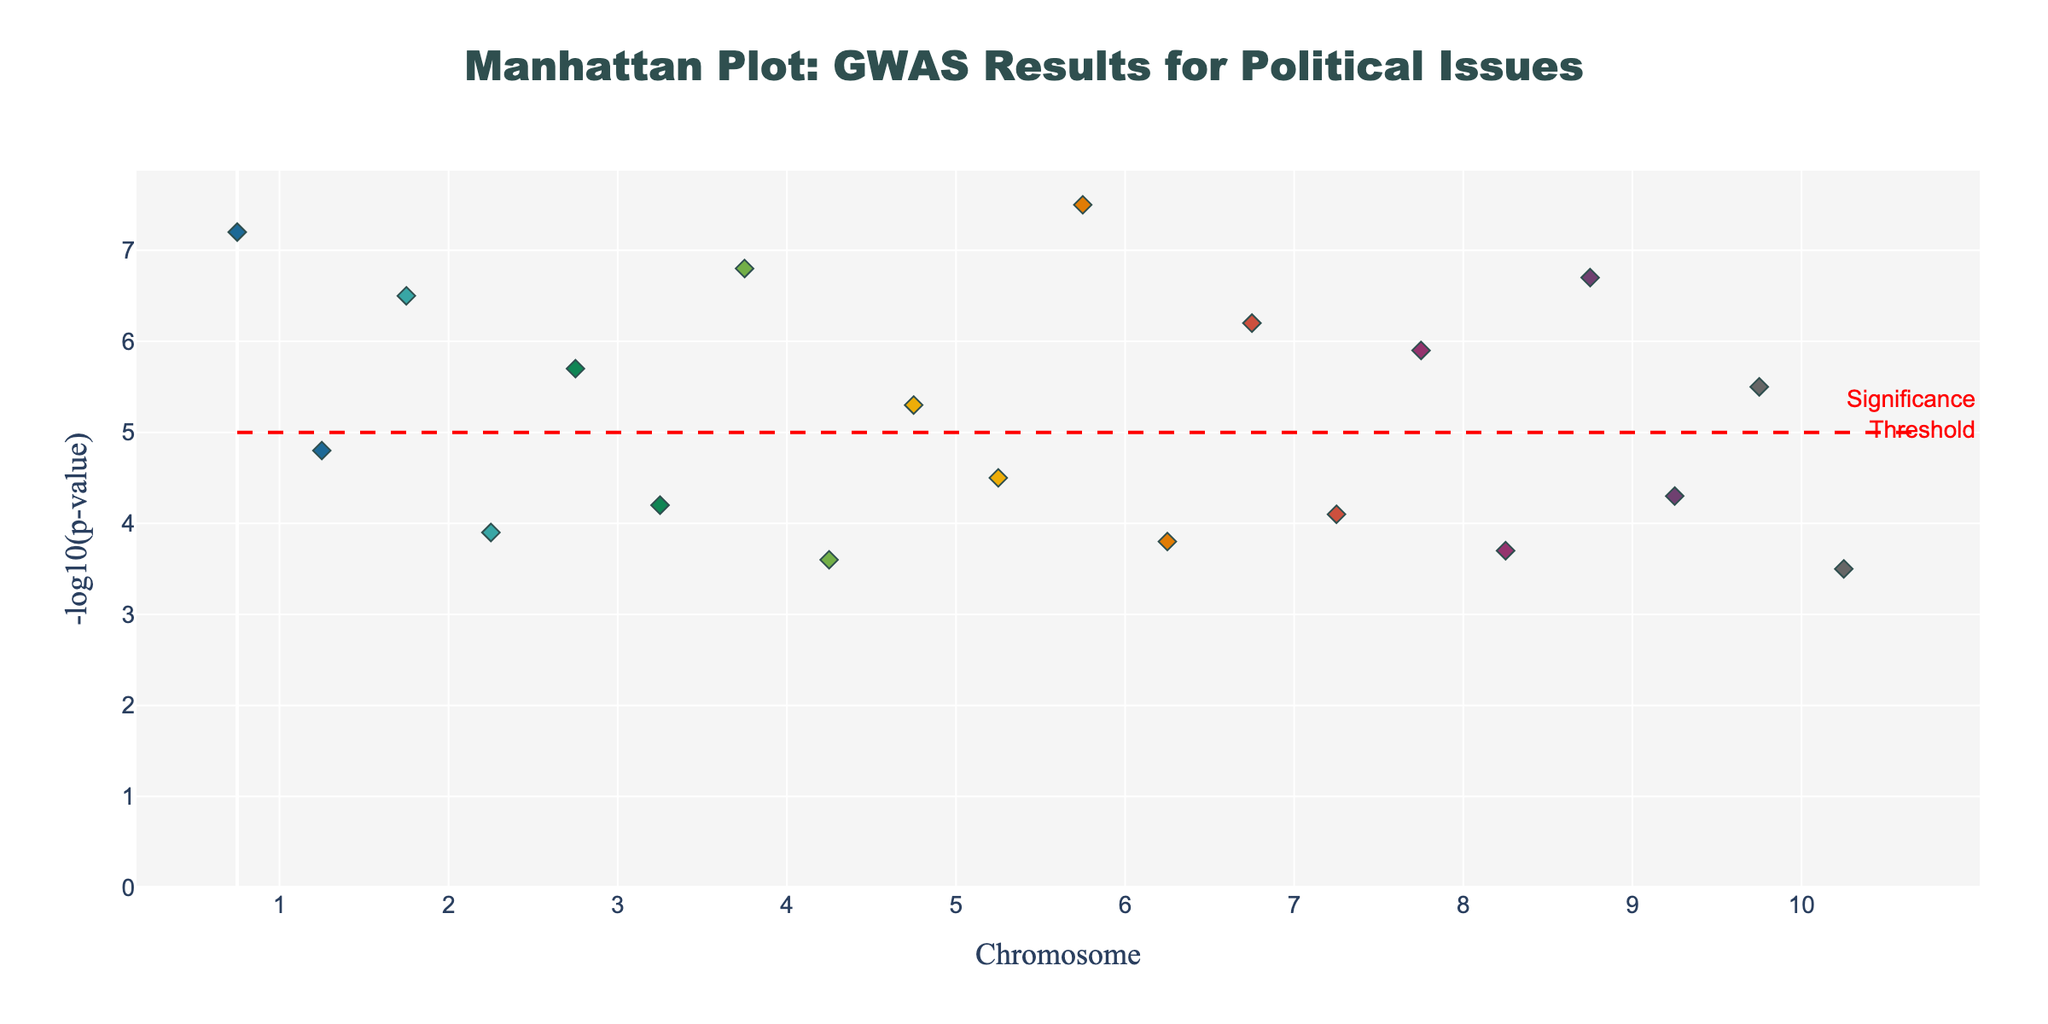what's the title of the plot? The plot's title is found at the top center of the figure and it is designed to provide a quick insight into what the plot represents.
Answer: Manhattan Plot: GWAS Results for Political Issues which chromosome shows the highest -log10(p-value) and what is this value? To find this information, locate the highest point on the y-axis which measures -log10(p-value). Check which chromosome this point belongs to.
Answer: Chromosome 6, 7.5 which chromosomes have data points above the significance threshold? The significance threshold line is drawn at y=5. Identify the chromosomes with any points above this horizontal line.
Answer: Chromosomes 1, 2, 4, 6, 7, 9 how many SNPs have a -log10(p-value) greater than 5? Count the number of data points that are above the significance threshold line (y=5) in the plot.
Answer: 8 what is the average -log10(p-value) for SNPs on chromosome 3? First, find all data points on chromosome 3. Sum their -log10(p-value) values and then divide by the number of points. Calculation: (5.7 + 4.2)/2 = 4.95
Answer: 4.95 which SNP related to an urban demographic issue has a higher -log10(p-value)? Locate the SNPs associated with urban demographics and compare their -log10(p-value) values. The SNPs are on Chromosome 2 and have values 3.9 for Climate Change.
Answer: rs7903146 compare the -log10(p-value) of rs1815739 on chromosome 2 and rs16969968 on chromosome 5. Which one is higher? Identify the exact -log10(p-value) values for the given SNPs and compare them. rs1815739 has 6.5 and rs16969968 has 4.5.
Answer: rs1815739 how is the significance threshold line indicated on the plot? Look for a horizontal line distinctly marked across the plot, with an annotation explaining its meaning. The line is at y=5.
Answer: Red dashed line which political issue has the highest association in the plot and for which demographic? Find the highest data point on the plot and look at the associated text for the trait and demographic. The highest point is at 7.5 for LGBTQ+ Rights, LGBTQ+.
Answer: LGBTQ+ Rights, LGBTQ+ which chromosomal data points are clustered closely together and what trait do they represent? Look for clusters of data points that are close in the x-axis values on a single chromosome, ignoring trivial visual gaps due to point distribution. Chromosome 5 between rs1800955 and rs16969968 show a slight cluster.
Answer: Drug Legalization, 30-44 years 